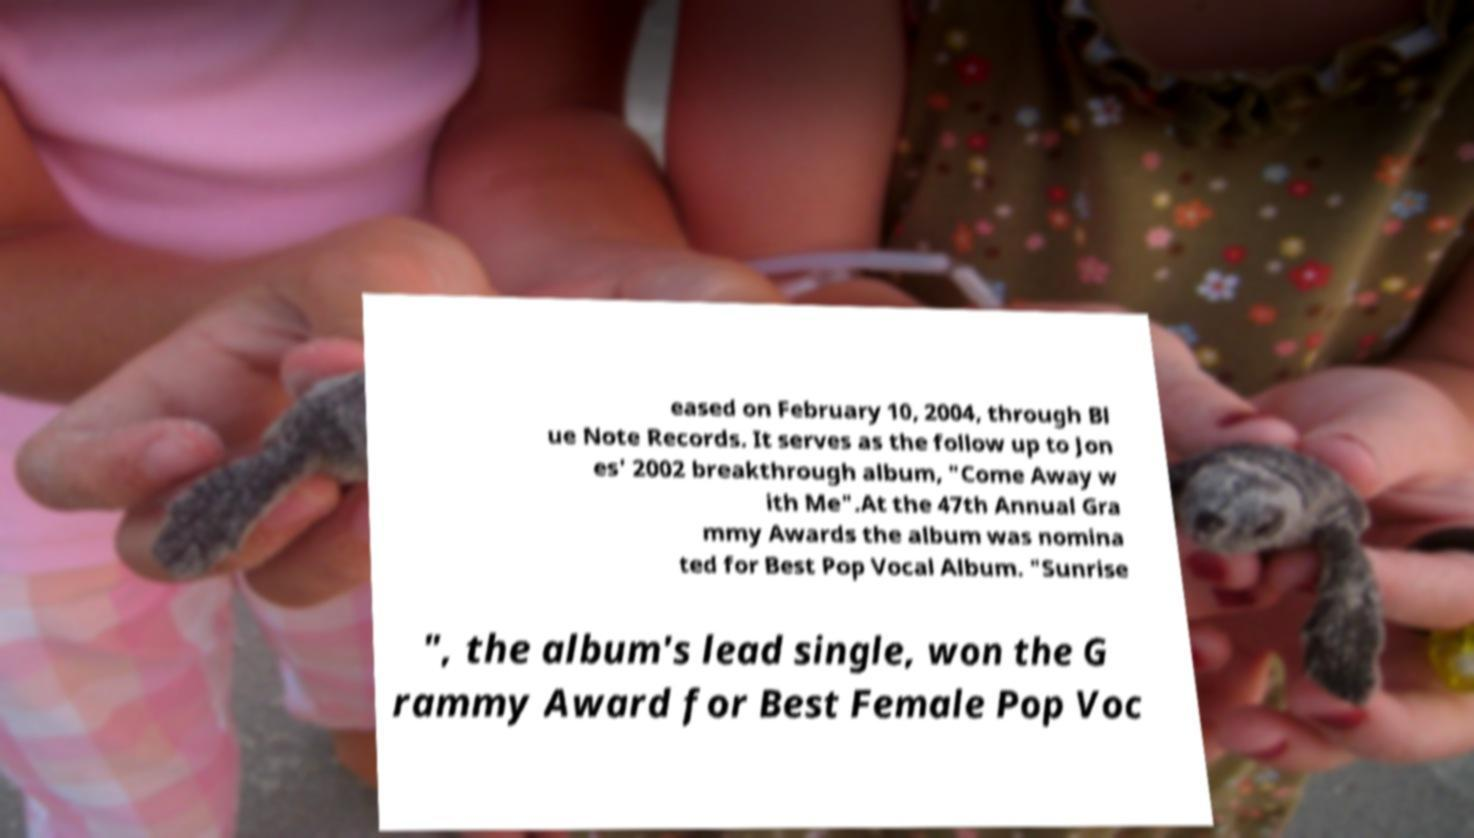What messages or text are displayed in this image? I need them in a readable, typed format. eased on February 10, 2004, through Bl ue Note Records. It serves as the follow up to Jon es' 2002 breakthrough album, "Come Away w ith Me".At the 47th Annual Gra mmy Awards the album was nomina ted for Best Pop Vocal Album. "Sunrise ", the album's lead single, won the G rammy Award for Best Female Pop Voc 